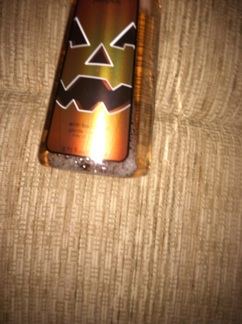What other products might use similar thematic designs? Similar thematic designs are commonly used in a variety of products such as candles, home decor items like throw pillows and blankets, party supplies like plates and napkins, and even clothing with Halloween motifs. 